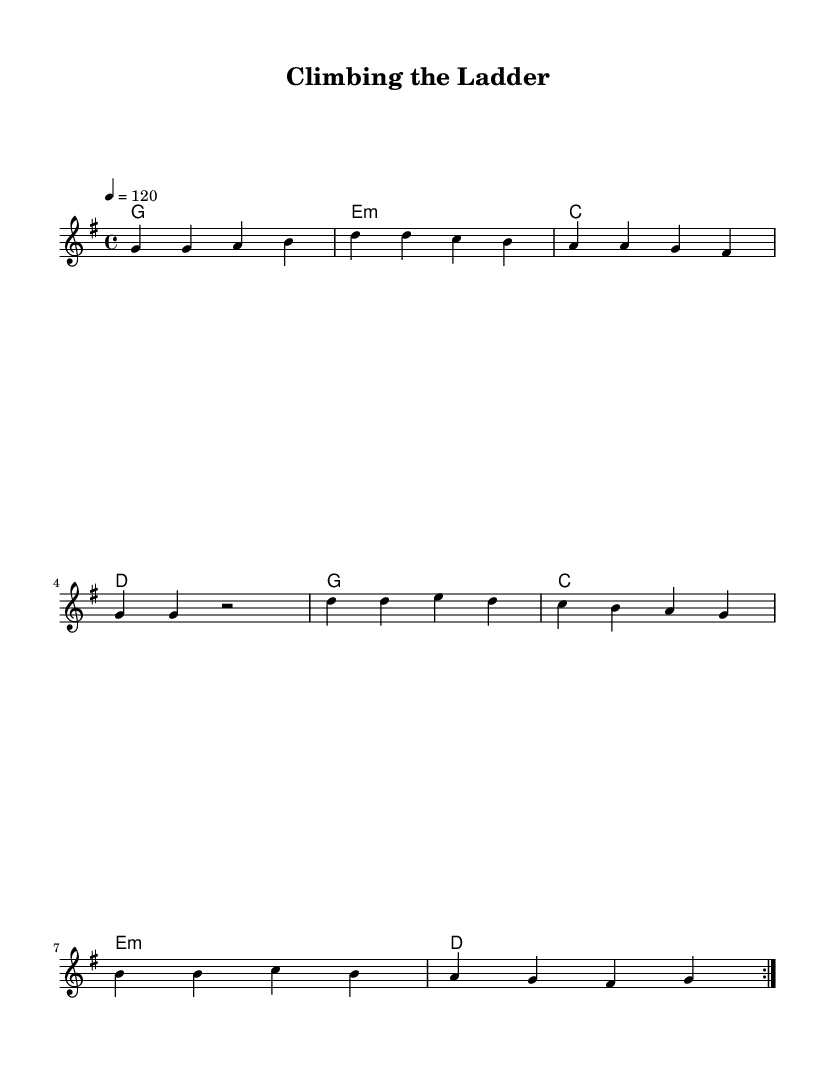What is the key signature of this music? The key signature is G major, which has one sharp (F#). It is indicated at the beginning of the staff.
Answer: G major What is the time signature of this piece? The time signature is 4/4, which means there are four beats in a measure and the quarter note gets one beat. This is indicated right after the key signature at the beginning of the staff.
Answer: 4/4 What is the tempo marking for this piece? The tempo marking is 120 BPM, which indicates that the piece should be played at a speed of 120 beats per minute. It is specified as "4 = 120" at the beginning of the score.
Answer: 120 How many measures are there in the melody? The melody consists of 8 measures, which can be counted by looking at each group of bars in the staff. Each vertical line (bar line) indicates the end of a measure.
Answer: 8 What is the primary chord progression used in the harmonies? The primary chord progression is G - E minor - C - D. By analyzing the harmonic structure, the chords repeat over two cycles.
Answer: G - E minor - C - D Which voice is indicated on the score? The score indicates a single voice labeled "melody," which is where the main tune is played. This is specified on the staff with the label.
Answer: melody What is the repeated section in the song? The section that is repeated is indicated by the "volta" markings, signaling that the viewer should repeat the previous passage twice. This is found in the melody and harmonies.
Answer: Volta 